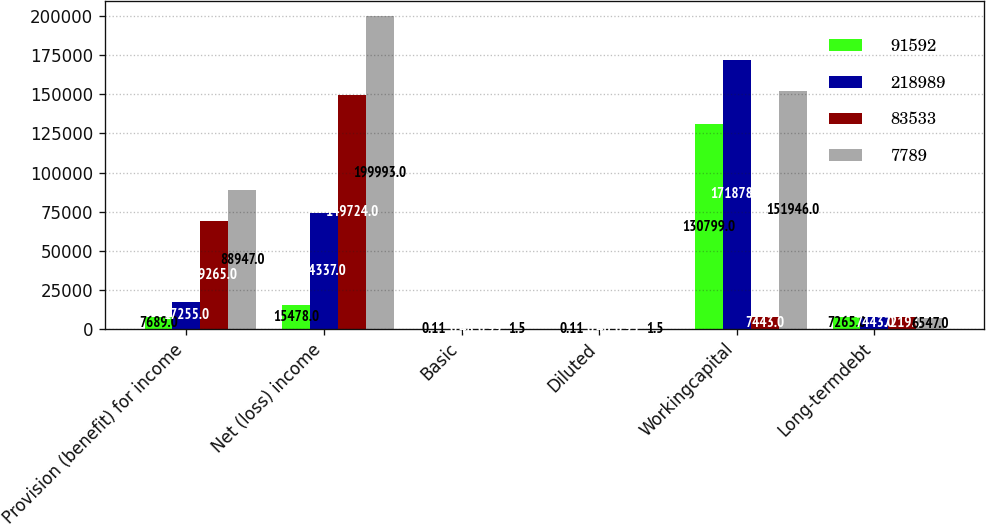Convert chart to OTSL. <chart><loc_0><loc_0><loc_500><loc_500><stacked_bar_chart><ecel><fcel>Provision (benefit) for income<fcel>Net (loss) income<fcel>Basic<fcel>Diluted<fcel>Workingcapital<fcel>Long-termdebt<nl><fcel>91592<fcel>7689<fcel>15478<fcel>0.11<fcel>0.11<fcel>130799<fcel>7265<nl><fcel>218989<fcel>17255<fcel>74337<fcel>0.48<fcel>0.46<fcel>171878<fcel>7443<nl><fcel>83533<fcel>69265<fcel>149724<fcel>0.99<fcel>0.95<fcel>7443<fcel>7219<nl><fcel>7789<fcel>88947<fcel>199993<fcel>1.5<fcel>1.5<fcel>151946<fcel>6547<nl></chart> 